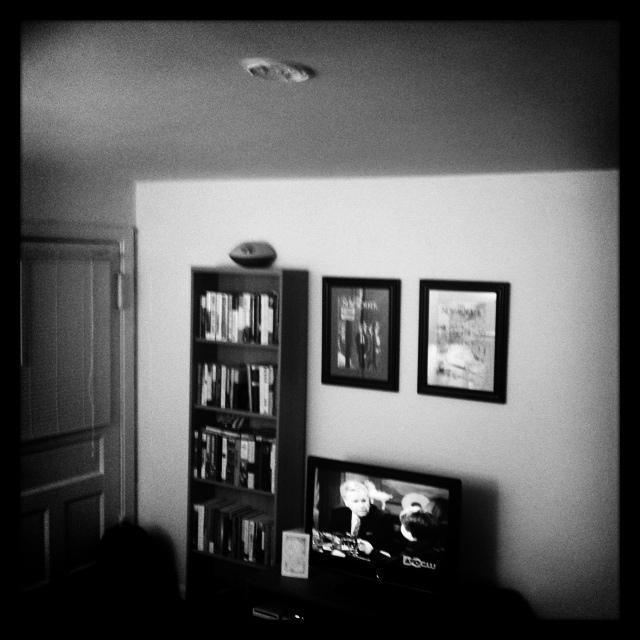How many books are visible?
Give a very brief answer. 2. How many people are sitting down?
Give a very brief answer. 0. 